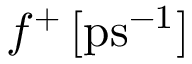<formula> <loc_0><loc_0><loc_500><loc_500>f ^ { + } \, [ p s ^ { - 1 } ]</formula> 